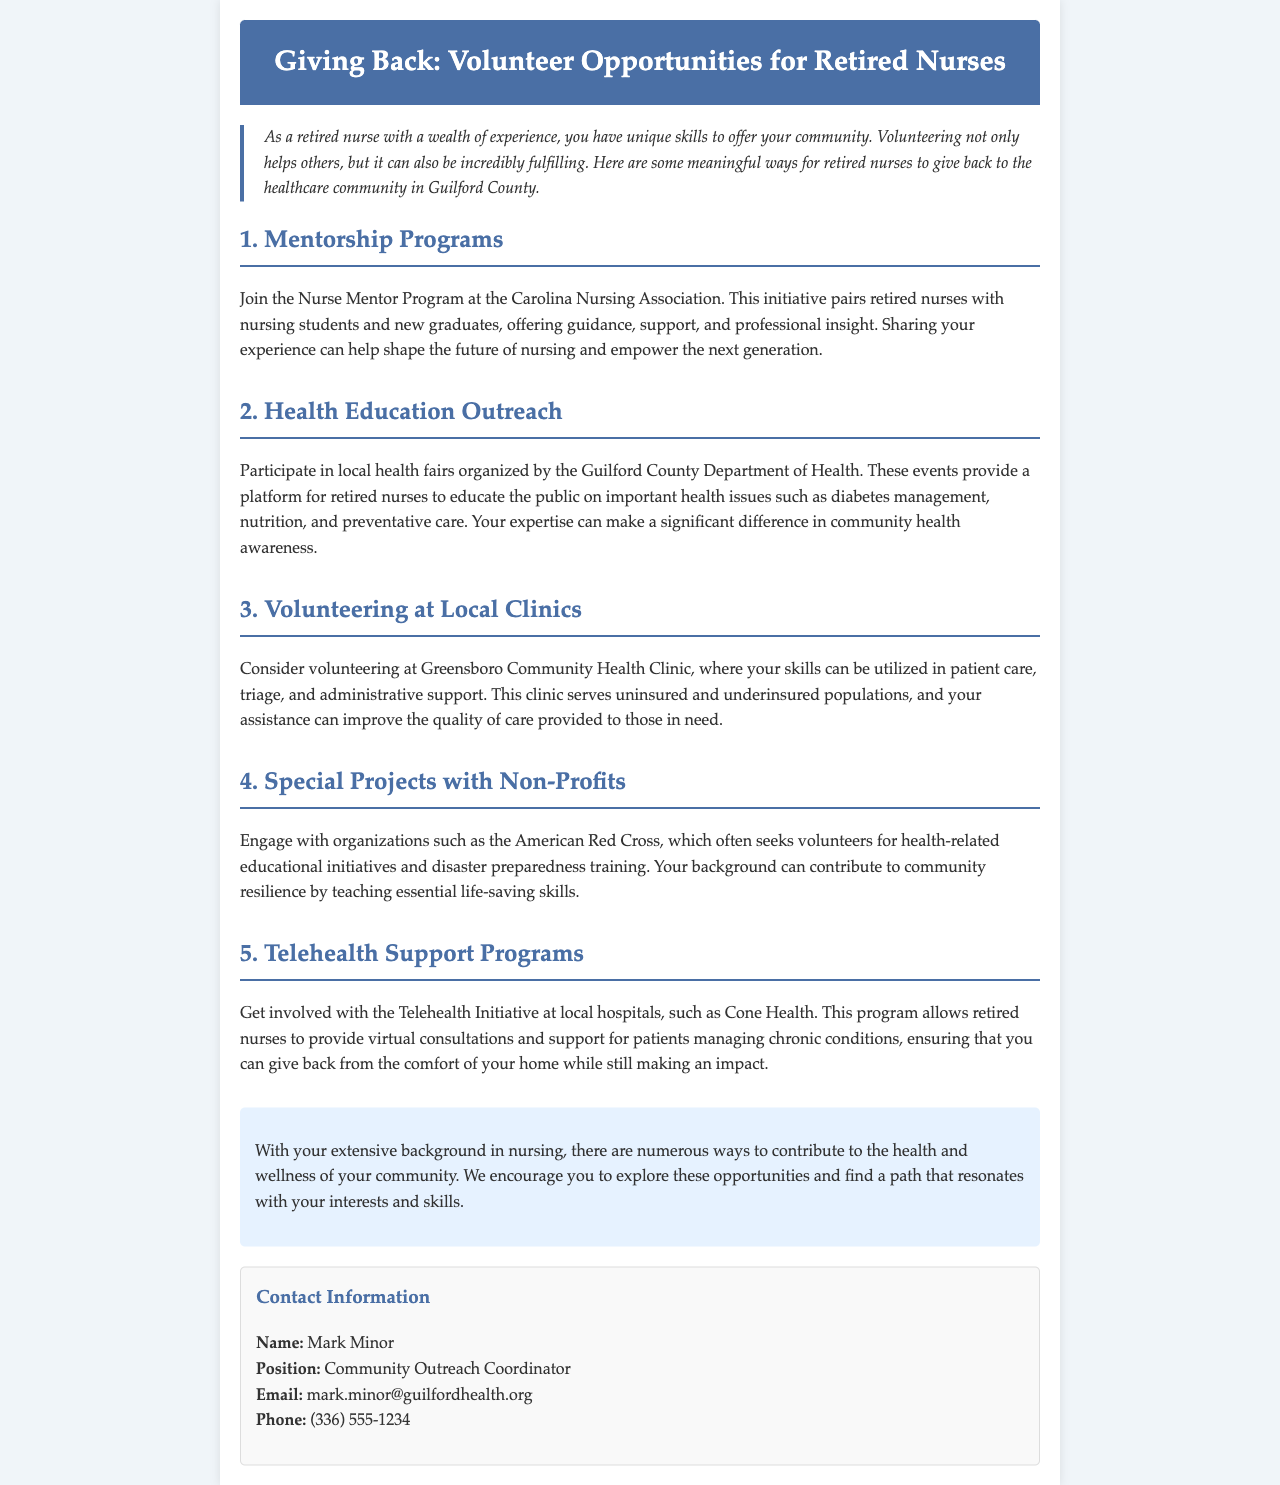What is the title of the newsletter? The title is prominently displayed at the top of the document, which is "Giving Back: Volunteer Opportunities for Retired Nurses."
Answer: Giving Back: Volunteer Opportunities for Retired Nurses Who is the contact person for the outreach? The contact person's name is provided in the contact information section, highlighting their role and availability for inquiries.
Answer: Mark Minor What is the email address of the contact person? The email address is listed under contact information, making it easy for readers to reach out for more details.
Answer: mark.minor@guilfordhealth.org What is the first volunteer opportunity mentioned? The first opportunity is described in the section headings, which are organized numerically for clarity.
Answer: Mentorship Programs How can retired nurses contribute to community health awareness? The document details specific opportunities for retired nurses to engage in health education, showing how their experience is valuable.
Answer: By participating in local health fairs How does telehealth support programs allow involvement from home? The document mentions virtual consultations, indicating how retired nurses can volunteer without visiting healthcare facilities.
Answer: By providing virtual consultations What organization seeks volunteers for disaster preparedness training? The document lists organizations that require volunteer support, emphasizing the diverse engagement opportunities available.
Answer: American Red Cross What is the phone number for the contact person? The phone number is part of the provided contact information, allowing for direct communication.
Answer: (336) 555-1234 